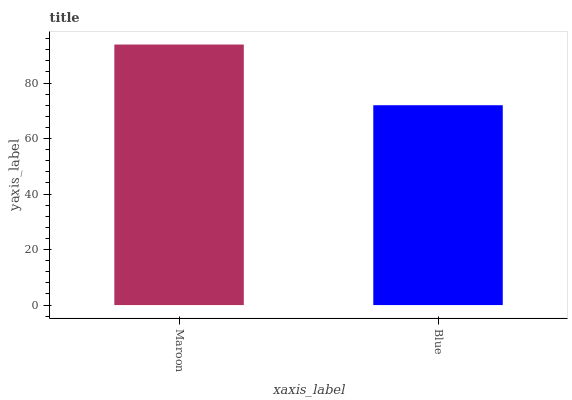Is Blue the minimum?
Answer yes or no. Yes. Is Maroon the maximum?
Answer yes or no. Yes. Is Blue the maximum?
Answer yes or no. No. Is Maroon greater than Blue?
Answer yes or no. Yes. Is Blue less than Maroon?
Answer yes or no. Yes. Is Blue greater than Maroon?
Answer yes or no. No. Is Maroon less than Blue?
Answer yes or no. No. Is Maroon the high median?
Answer yes or no. Yes. Is Blue the low median?
Answer yes or no. Yes. Is Blue the high median?
Answer yes or no. No. Is Maroon the low median?
Answer yes or no. No. 